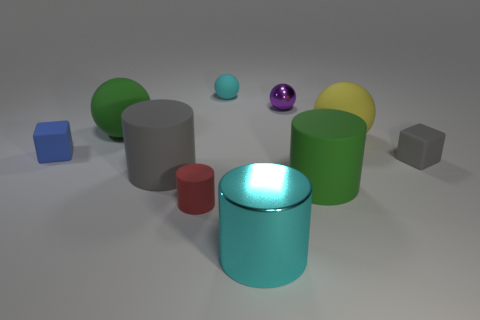Subtract all cyan metal cubes. Subtract all cyan balls. How many objects are left? 9 Add 5 cyan rubber balls. How many cyan rubber balls are left? 6 Add 5 small objects. How many small objects exist? 10 Subtract all purple balls. How many balls are left? 3 Subtract all large gray matte cylinders. How many cylinders are left? 3 Subtract 0 green blocks. How many objects are left? 10 Subtract all spheres. How many objects are left? 6 Subtract 1 cubes. How many cubes are left? 1 Subtract all yellow cubes. Subtract all red balls. How many cubes are left? 2 Subtract all brown cylinders. How many blue blocks are left? 1 